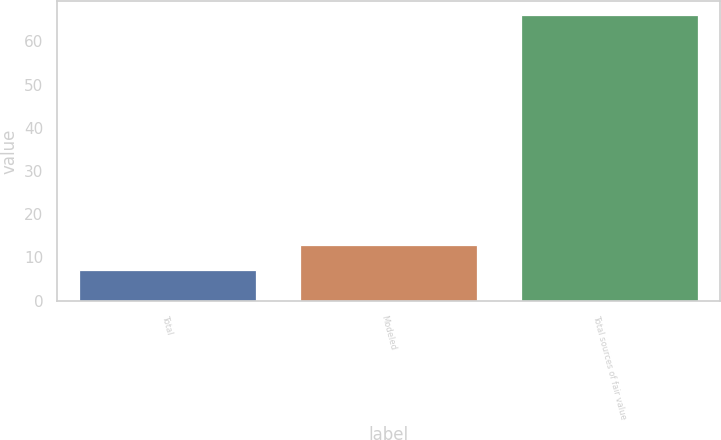Convert chart to OTSL. <chart><loc_0><loc_0><loc_500><loc_500><bar_chart><fcel>Total<fcel>Modeled<fcel>Total sources of fair value<nl><fcel>7<fcel>12.9<fcel>66<nl></chart> 